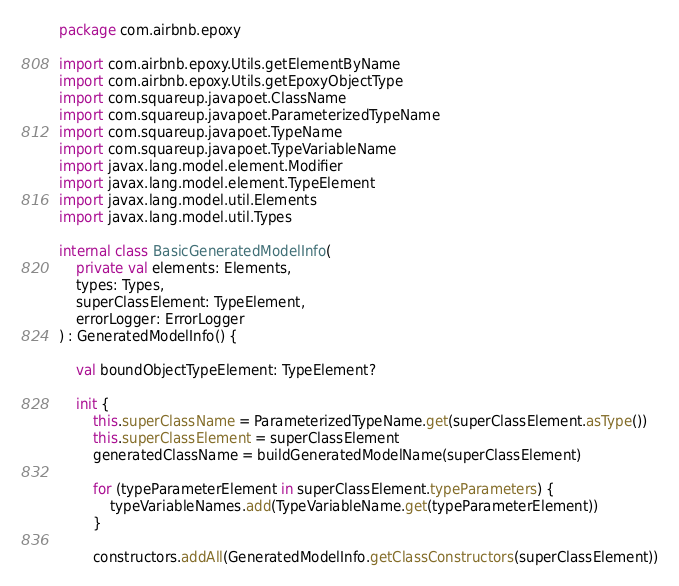Convert code to text. <code><loc_0><loc_0><loc_500><loc_500><_Kotlin_>package com.airbnb.epoxy

import com.airbnb.epoxy.Utils.getElementByName
import com.airbnb.epoxy.Utils.getEpoxyObjectType
import com.squareup.javapoet.ClassName
import com.squareup.javapoet.ParameterizedTypeName
import com.squareup.javapoet.TypeName
import com.squareup.javapoet.TypeVariableName
import javax.lang.model.element.Modifier
import javax.lang.model.element.TypeElement
import javax.lang.model.util.Elements
import javax.lang.model.util.Types

internal class BasicGeneratedModelInfo(
    private val elements: Elements,
    types: Types,
    superClassElement: TypeElement,
    errorLogger: ErrorLogger
) : GeneratedModelInfo() {

    val boundObjectTypeElement: TypeElement?

    init {
        this.superClassName = ParameterizedTypeName.get(superClassElement.asType())
        this.superClassElement = superClassElement
        generatedClassName = buildGeneratedModelName(superClassElement)

        for (typeParameterElement in superClassElement.typeParameters) {
            typeVariableNames.add(TypeVariableName.get(typeParameterElement))
        }

        constructors.addAll(GeneratedModelInfo.getClassConstructors(superClassElement))</code> 